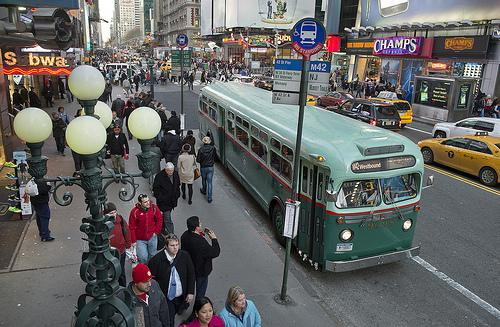Question: when is it?
Choices:
A. Early morning.
B. Midnight.
C. Late night.
D. Day time.
Answer with the letter. Answer: D Question: what are the people doing?
Choices:
A. Running.
B. Talking.
C. Reading.
D. Walking.
Answer with the letter. Answer: D Question: why are the people wearing jackets?
Choices:
A. It's warm.
B. It's hot.
C. It's normal.
D. It's cold.
Answer with the letter. Answer: D 